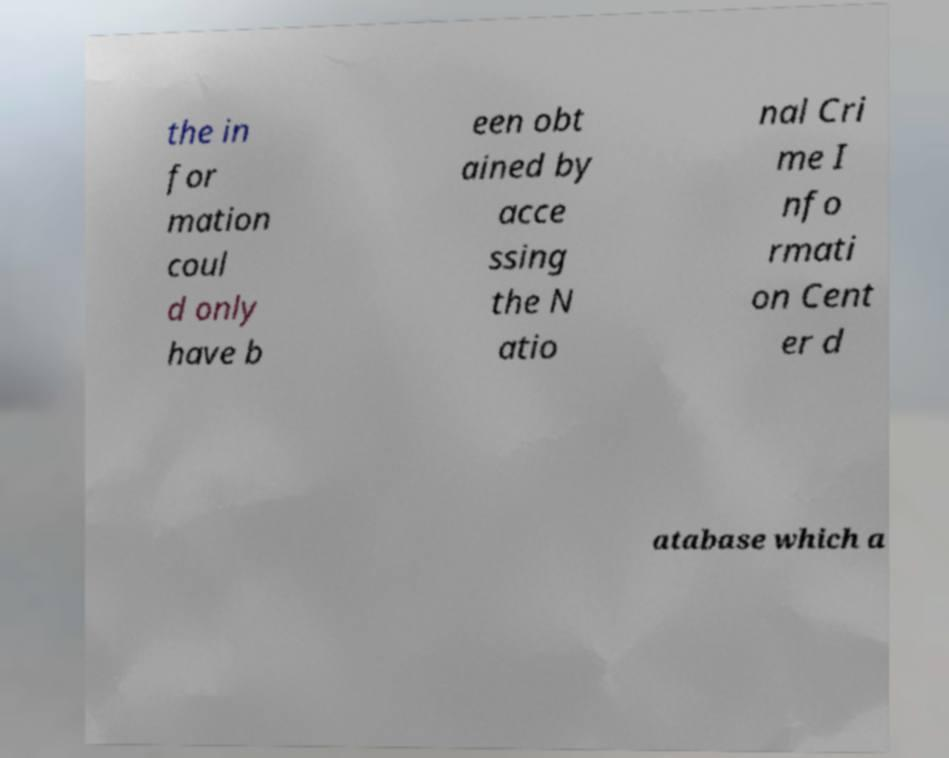Please read and relay the text visible in this image. What does it say? the in for mation coul d only have b een obt ained by acce ssing the N atio nal Cri me I nfo rmati on Cent er d atabase which a 